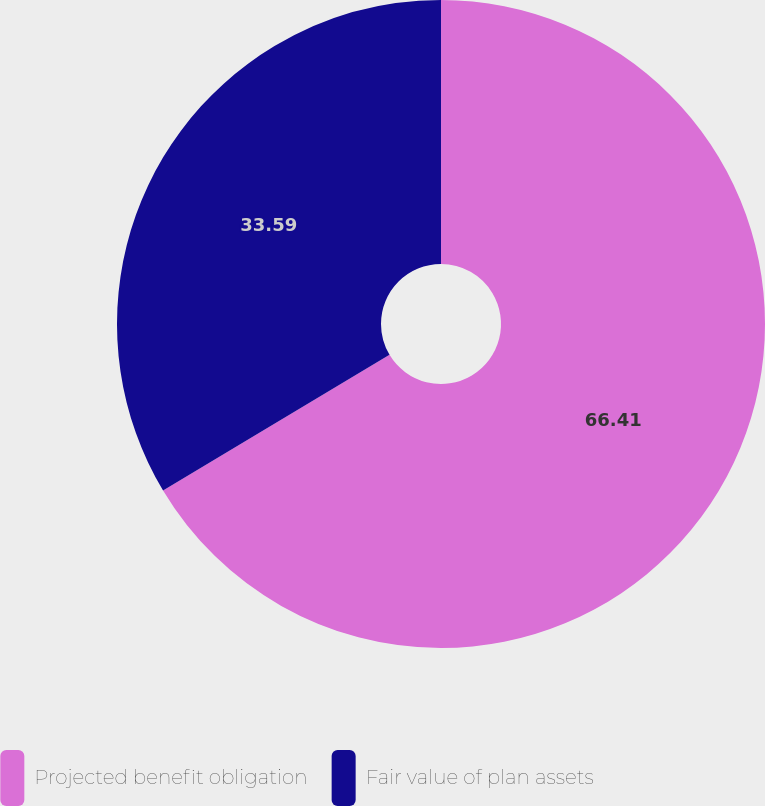Convert chart. <chart><loc_0><loc_0><loc_500><loc_500><pie_chart><fcel>Projected benefit obligation<fcel>Fair value of plan assets<nl><fcel>66.41%<fcel>33.59%<nl></chart> 